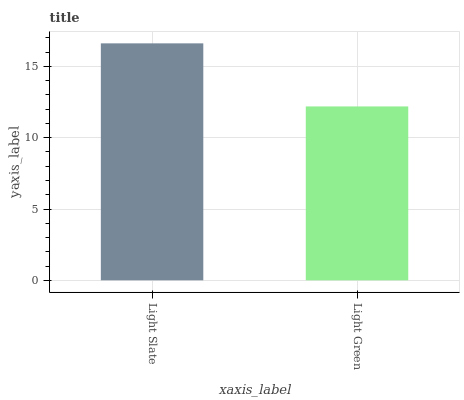Is Light Green the minimum?
Answer yes or no. Yes. Is Light Slate the maximum?
Answer yes or no. Yes. Is Light Green the maximum?
Answer yes or no. No. Is Light Slate greater than Light Green?
Answer yes or no. Yes. Is Light Green less than Light Slate?
Answer yes or no. Yes. Is Light Green greater than Light Slate?
Answer yes or no. No. Is Light Slate less than Light Green?
Answer yes or no. No. Is Light Slate the high median?
Answer yes or no. Yes. Is Light Green the low median?
Answer yes or no. Yes. Is Light Green the high median?
Answer yes or no. No. Is Light Slate the low median?
Answer yes or no. No. 